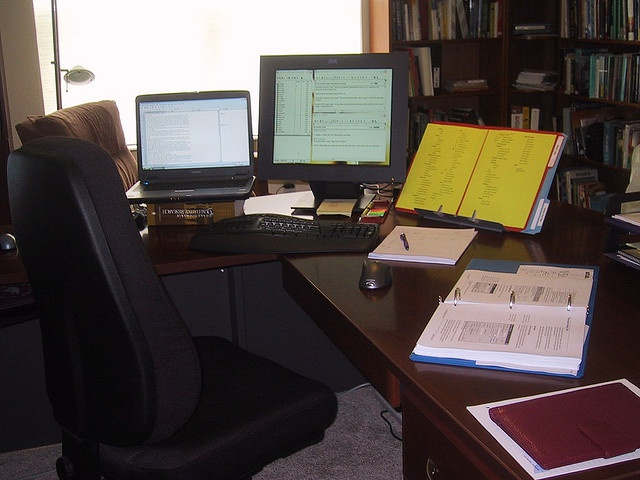Describe the objects in this image and their specific colors. I can see chair in gray and black tones, book in gray, black, olive, and maroon tones, tv in gray, darkgray, and black tones, book in gray, darkgray, lavender, and lightgray tones, and laptop in gray, lightgray, and black tones in this image. 